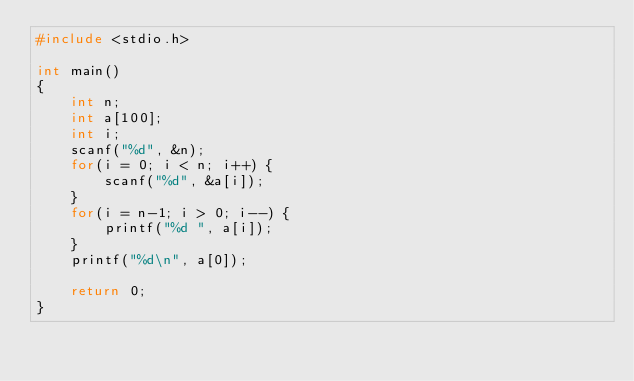Convert code to text. <code><loc_0><loc_0><loc_500><loc_500><_C_>#include <stdio.h>

int main()
{
    int n;
    int a[100];
    int i;
    scanf("%d", &n);
    for(i = 0; i < n; i++) {
        scanf("%d", &a[i]);
    }
    for(i = n-1; i > 0; i--) {
        printf("%d ", a[i]);
    }
    printf("%d\n", a[0]);

    return 0;
}
</code> 